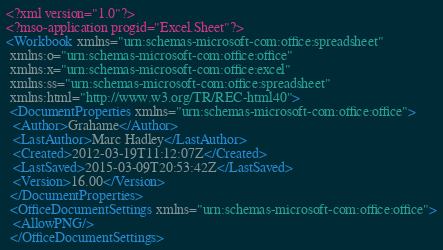<code> <loc_0><loc_0><loc_500><loc_500><_XML_><?xml version="1.0"?>
<?mso-application progid="Excel.Sheet"?>
<Workbook xmlns="urn:schemas-microsoft-com:office:spreadsheet"
 xmlns:o="urn:schemas-microsoft-com:office:office"
 xmlns:x="urn:schemas-microsoft-com:office:excel"
 xmlns:ss="urn:schemas-microsoft-com:office:spreadsheet"
 xmlns:html="http://www.w3.org/TR/REC-html40">
 <DocumentProperties xmlns="urn:schemas-microsoft-com:office:office">
  <Author>Grahame</Author>
  <LastAuthor>Marc Hadley</LastAuthor>
  <Created>2012-03-19T11:12:07Z</Created>
  <LastSaved>2015-03-09T20:53:42Z</LastSaved>
  <Version>16.00</Version>
 </DocumentProperties>
 <OfficeDocumentSettings xmlns="urn:schemas-microsoft-com:office:office">
  <AllowPNG/>
 </OfficeDocumentSettings></code> 